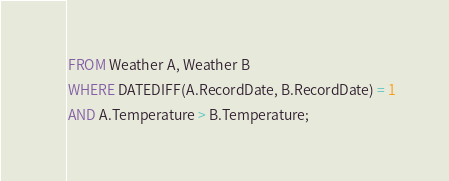<code> <loc_0><loc_0><loc_500><loc_500><_SQL_>FROM Weather A, Weather B
WHERE DATEDIFF(A.RecordDate, B.RecordDate) = 1
AND A.Temperature > B.Temperature;
</code> 